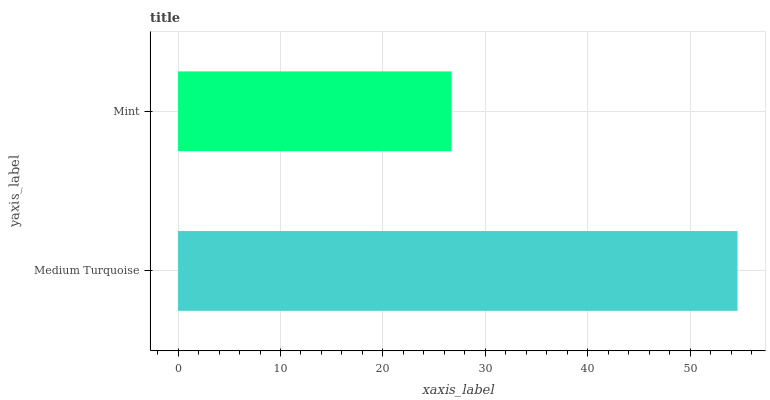Is Mint the minimum?
Answer yes or no. Yes. Is Medium Turquoise the maximum?
Answer yes or no. Yes. Is Mint the maximum?
Answer yes or no. No. Is Medium Turquoise greater than Mint?
Answer yes or no. Yes. Is Mint less than Medium Turquoise?
Answer yes or no. Yes. Is Mint greater than Medium Turquoise?
Answer yes or no. No. Is Medium Turquoise less than Mint?
Answer yes or no. No. Is Medium Turquoise the high median?
Answer yes or no. Yes. Is Mint the low median?
Answer yes or no. Yes. Is Mint the high median?
Answer yes or no. No. Is Medium Turquoise the low median?
Answer yes or no. No. 